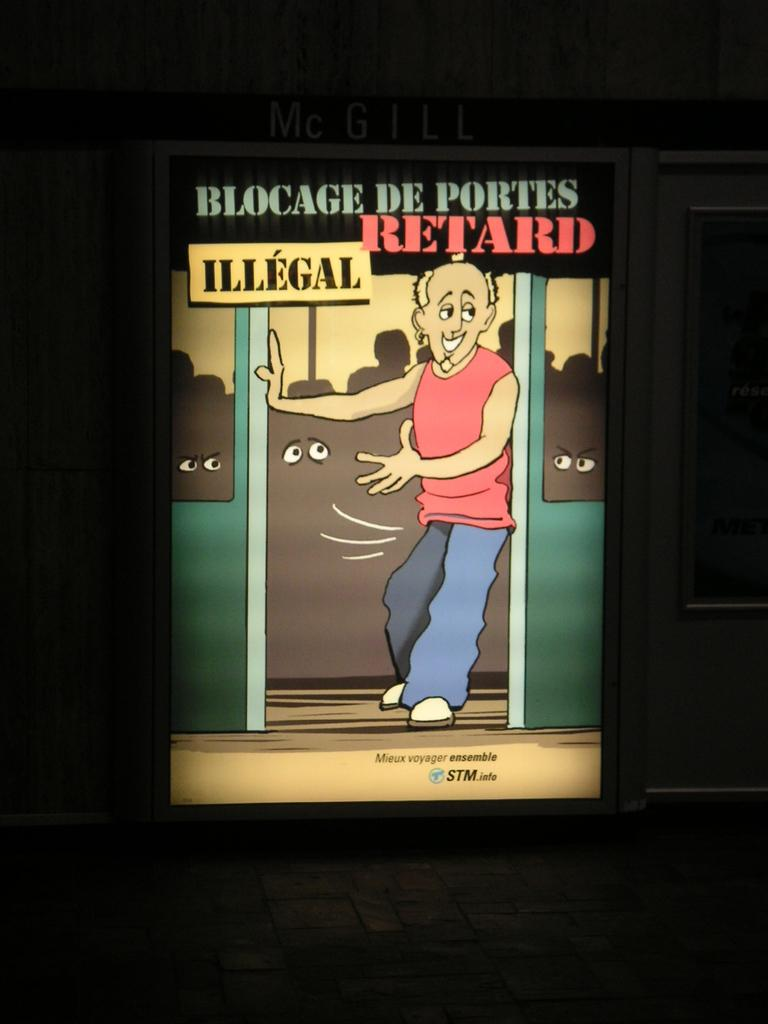What is the main subject of the image? There is a person in the image. Can you describe what is written in the image? Unfortunately, the specific content of what is written cannot be determined from the provided facts. How many bears are visible in the image? There are no bears present in the image. What type of scale is being used by the brothers in the image? There is no mention of a scale or brothers in the image, so this question cannot be answered. 